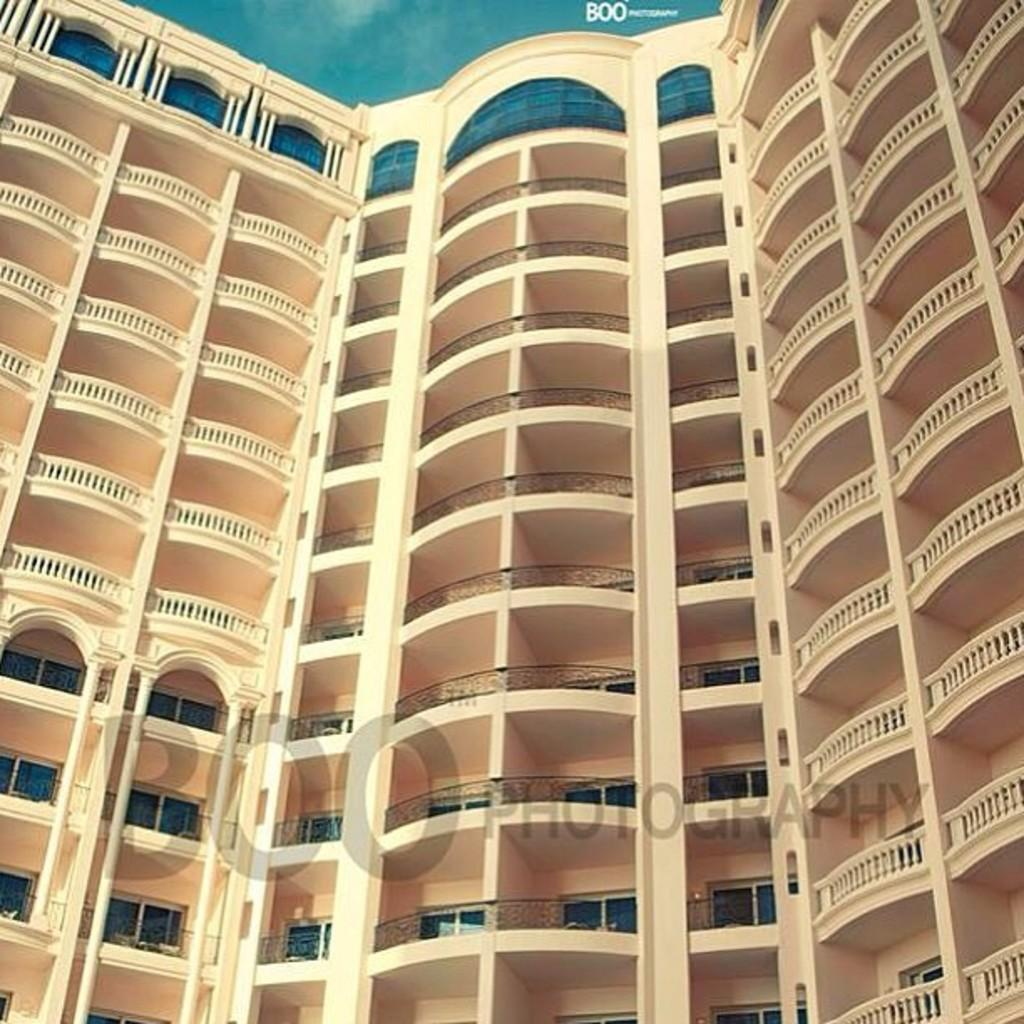What type of structure is in the image? There is a building in the image. What features can be seen on the building? The building has windows and balconies. Are there any other objects visible on the building? Yes, there are other objects visible on the building. What is the condition of the image itself? Watermarks are present on the image. What shape is the parcel that is being delivered on the building? There is no parcel visible in the image, so it is not possible to determine its shape. What type of fork is being used to eat on the balcony of the building? There is no fork or eating activity visible in the image; it only shows the building and its features. 